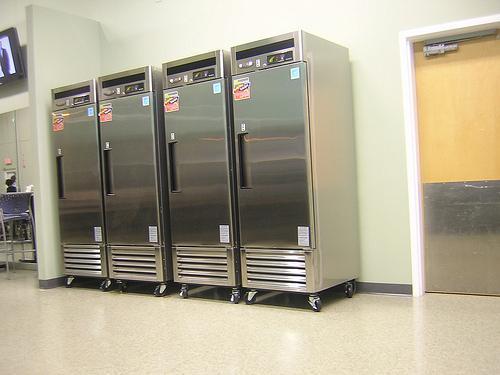How many appliances are in the picture?
Give a very brief answer. 4. 